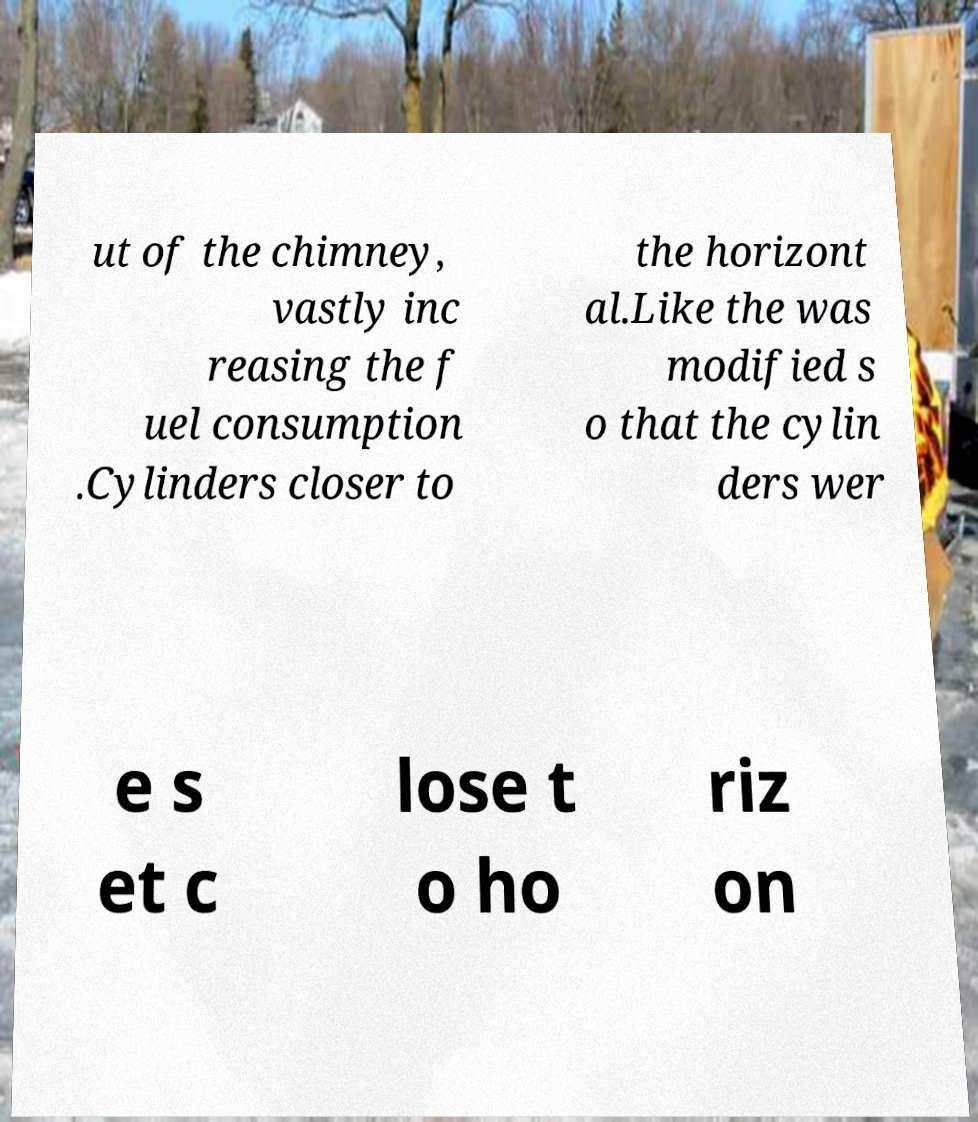Can you accurately transcribe the text from the provided image for me? ut of the chimney, vastly inc reasing the f uel consumption .Cylinders closer to the horizont al.Like the was modified s o that the cylin ders wer e s et c lose t o ho riz on 